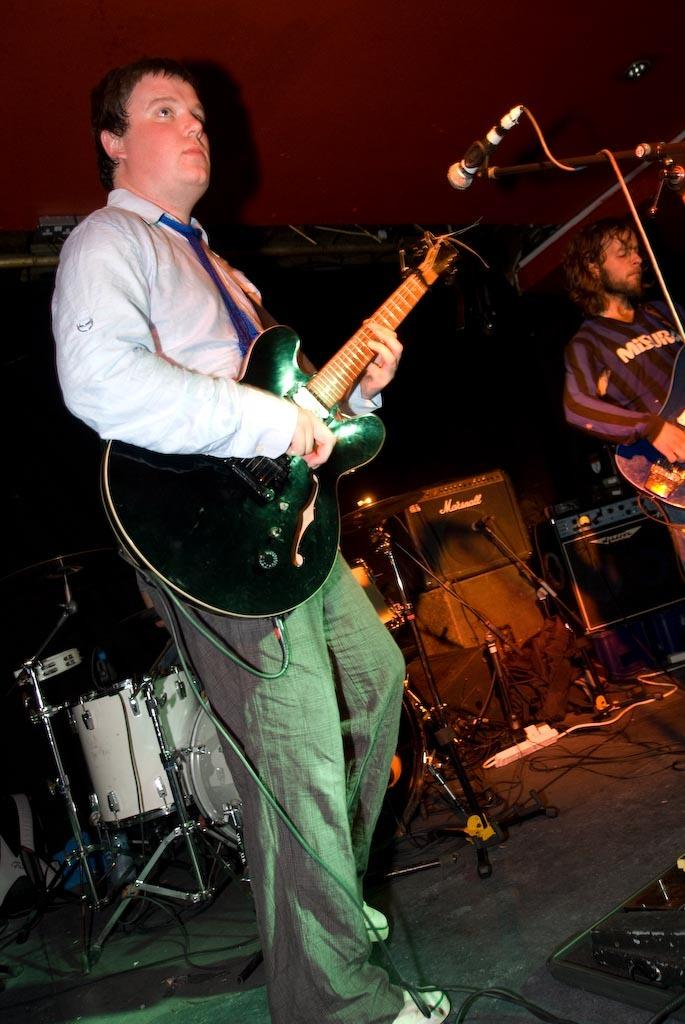What is the person in the image doing? The person is playing a guitar. What object is in front of the person? There is a microphone in front of the person. What other musical instruments can be seen in the image? There are musical drums at the back. What type of hot drink is the person holding while playing the guitar? There is no hot drink visible in the image; the person is playing a guitar and there are no other objects in their hands. 